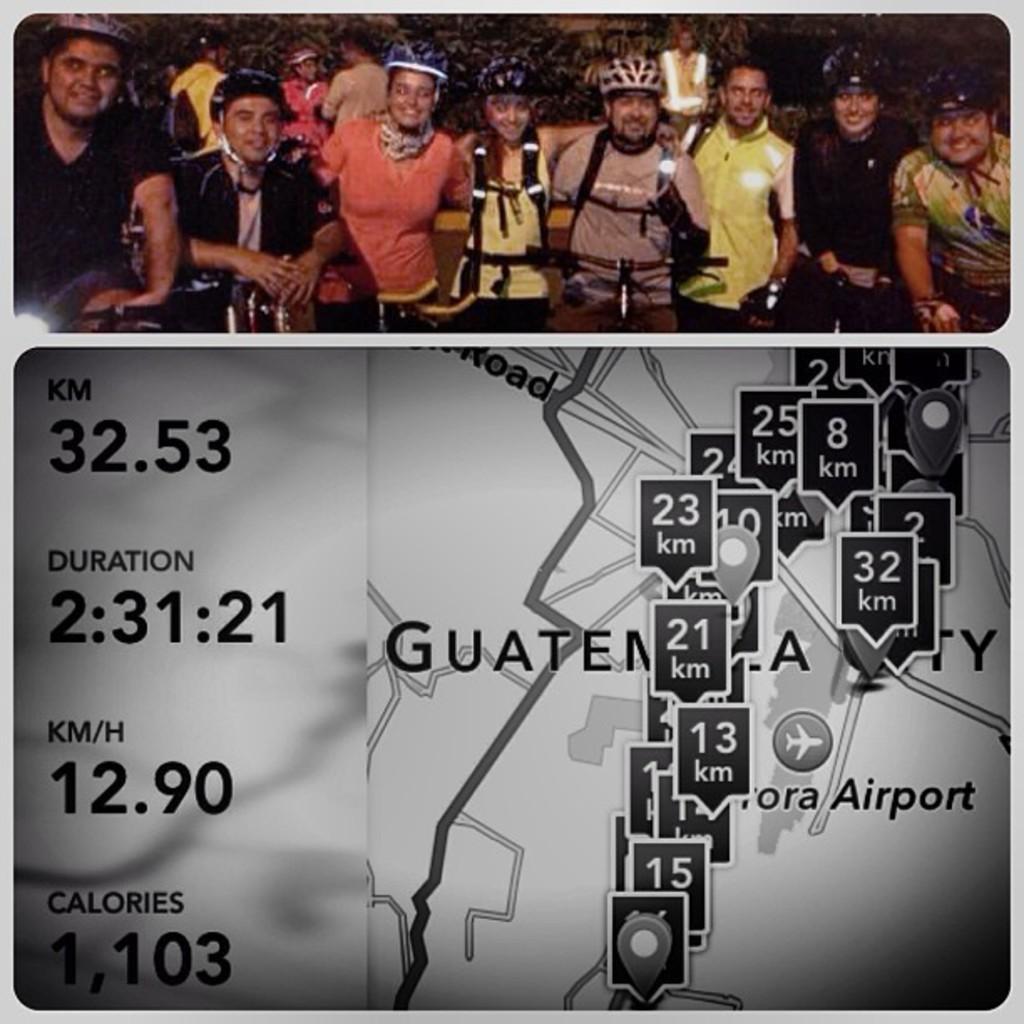In one or two sentences, can you explain what this image depicts? In this image we can see two images. At the top we can see few persons, bicycles, plants and objects. At the bottom we can see map, numbers and texts. 